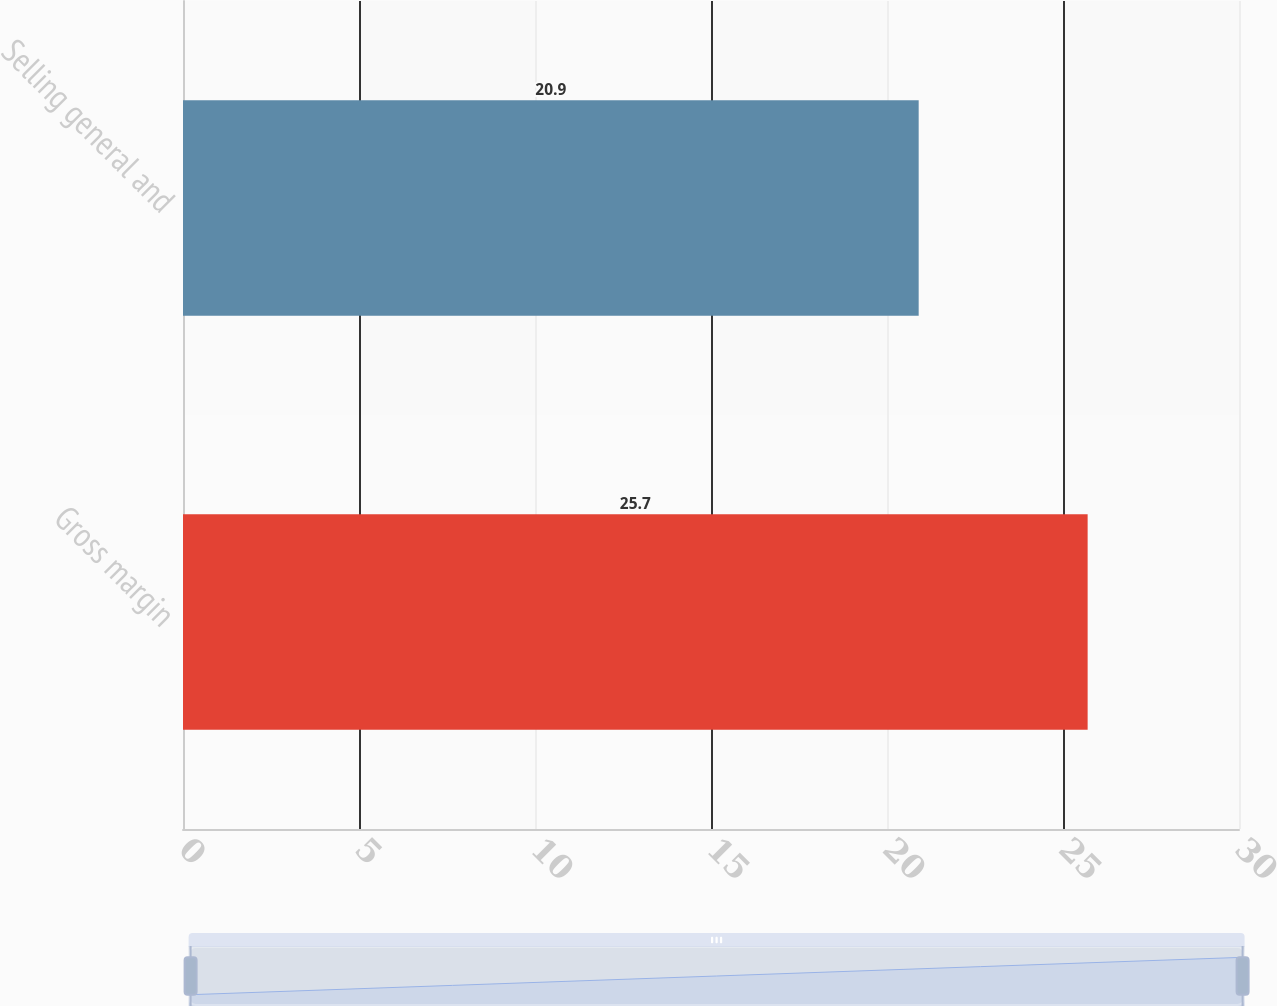Convert chart. <chart><loc_0><loc_0><loc_500><loc_500><bar_chart><fcel>Gross margin<fcel>Selling general and<nl><fcel>25.7<fcel>20.9<nl></chart> 